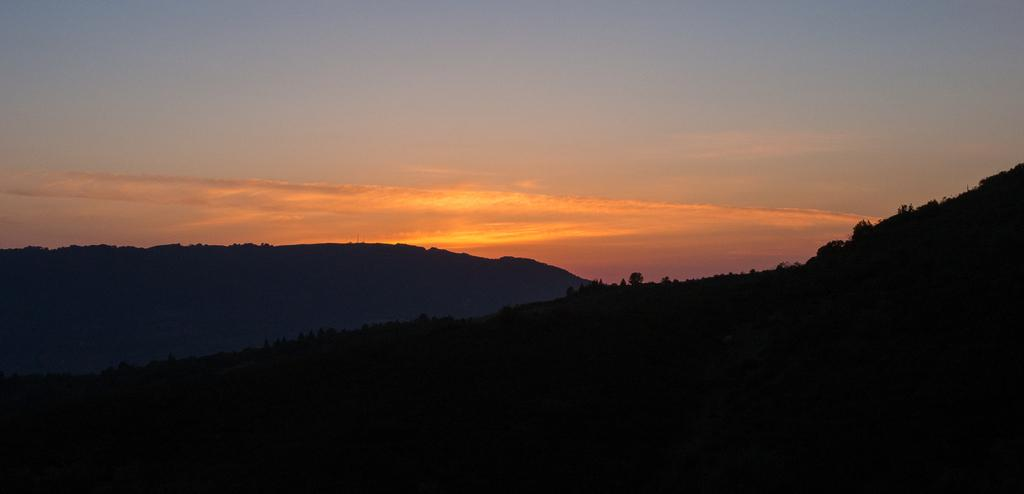What type of natural formation can be seen in the image? There are mountains in the image. What other natural elements are present in the image? There are trees in the image. What color are the clouds in the background? The clouds in the background are orange in color. What part of the sky is visible in the image? The sky is visible at the top of the image. What is the lighting condition at the bottom of the image? There is darkness at the bottom of the image. Can you tell me how the stranger is using magic to lead the mountains in the image? There is no stranger or magic present in the image; it features mountains, trees, and clouds. 